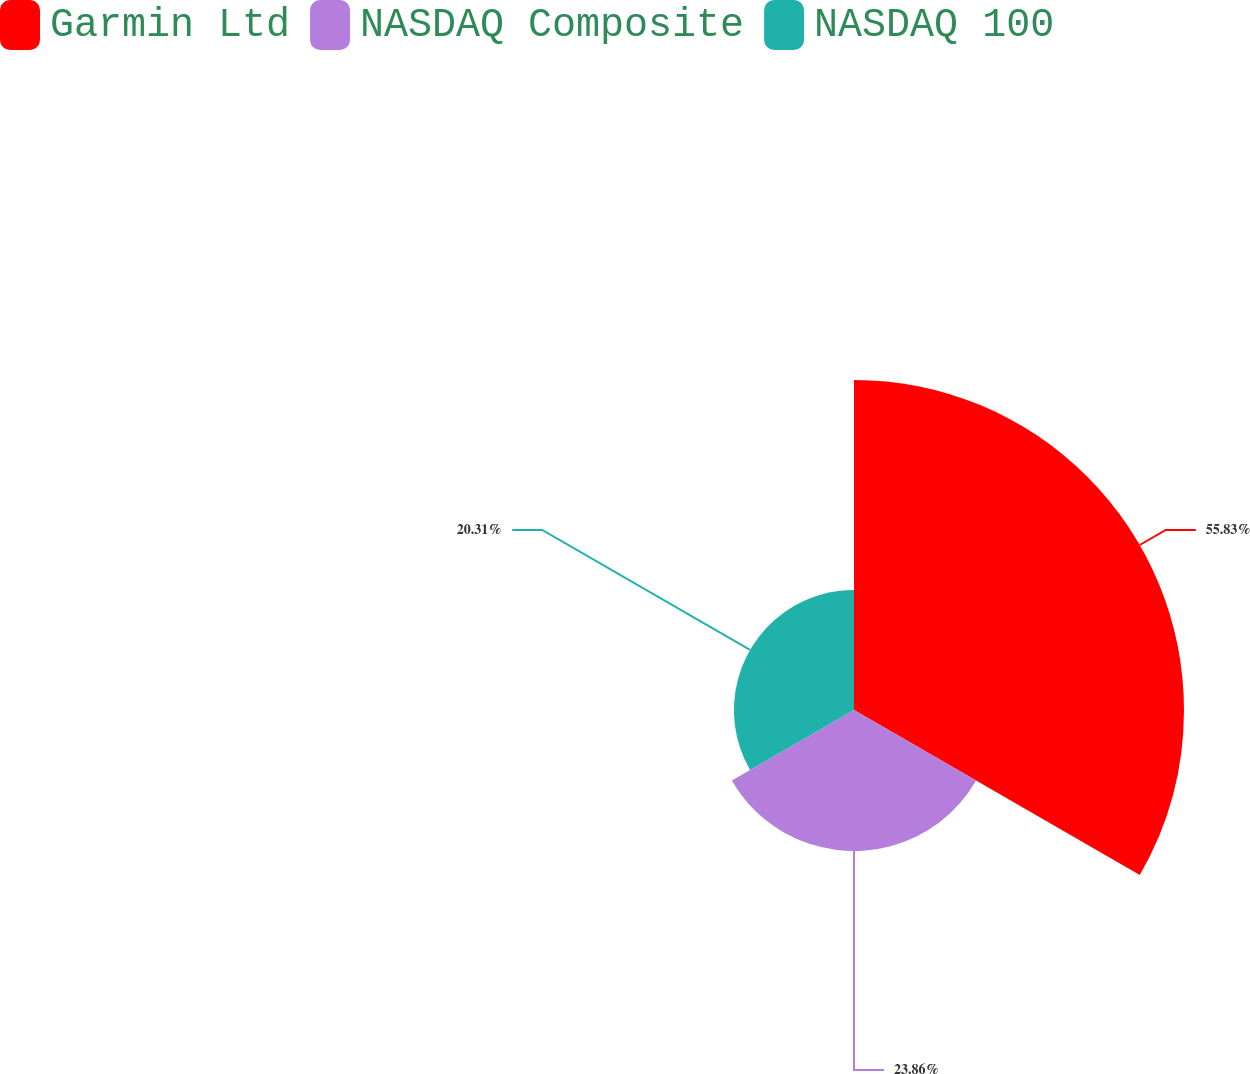Convert chart to OTSL. <chart><loc_0><loc_0><loc_500><loc_500><pie_chart><fcel>Garmin Ltd<fcel>NASDAQ Composite<fcel>NASDAQ 100<nl><fcel>55.82%<fcel>23.86%<fcel>20.31%<nl></chart> 